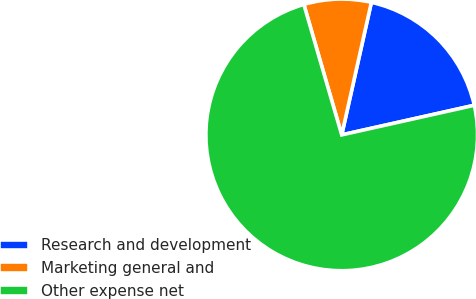Convert chart. <chart><loc_0><loc_0><loc_500><loc_500><pie_chart><fcel>Research and development<fcel>Marketing general and<fcel>Other expense net<nl><fcel>18.0%<fcel>8.0%<fcel>74.0%<nl></chart> 